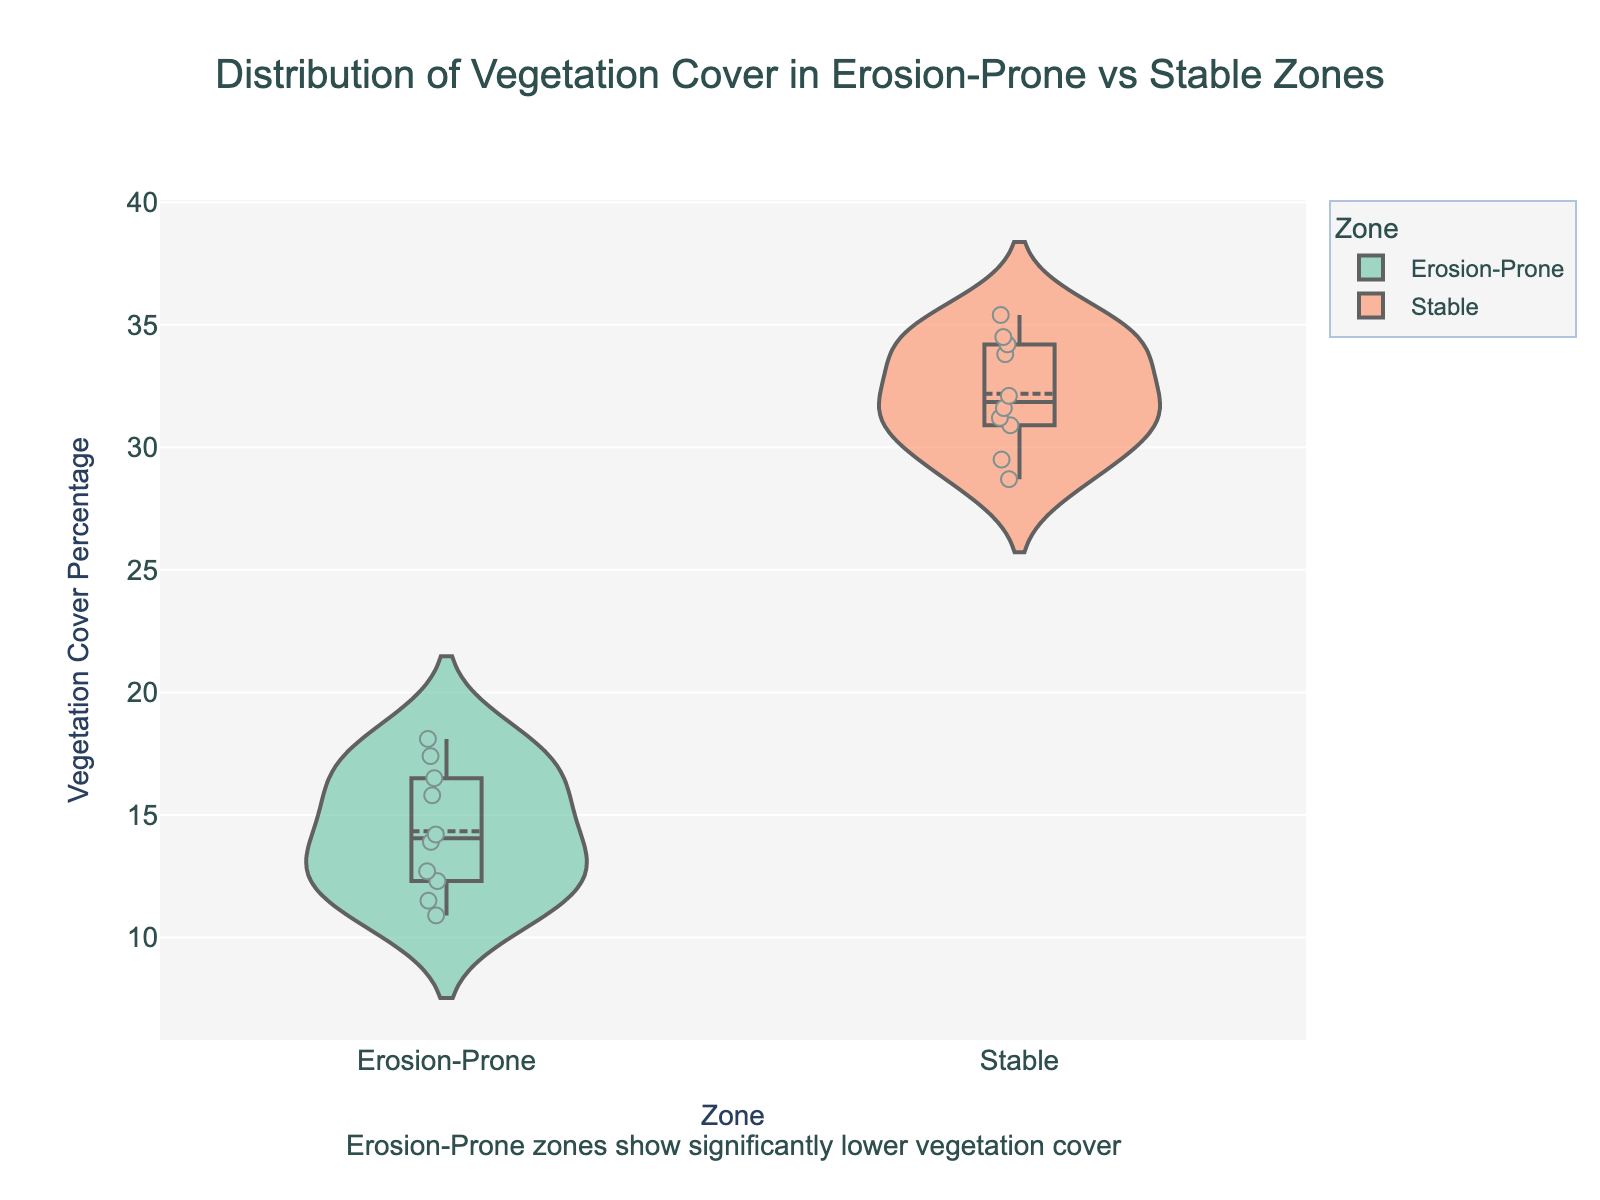What is the title of the chart? The title of the chart is located at the top and reads "Distribution of Vegetation Cover in Erosion-Prone vs Stable Zones".
Answer: Distribution of Vegetation Cover in Erosion-Prone vs Stable Zones How many zones are compared in this chart? The chart compares two zones, which can be identified by the separate violin plots labeled on the x-axis.
Answer: Two Which zone has a higher overall median vegetation cover percentage? By looking at the central line within each violin plot, the Stable zone has a higher median, which is clearly shown closer to the top.
Answer: Stable What is the approximate median vegetation cover percentage for the Erosion-Prone zone? The central line inside the violin plot for the Erosion-Prone zone indicates the median value, which appears to be around 14%.
Answer: 14% Compare the interquartile ranges (IQR) for both zones. Which zone has a wider IQR? The IQR is represented by the width of the box plot within the violin. The Stable zone has a wider IQR as its box plot is larger than that of the Erosion-Prone zone.
Answer: Stable Looking at the data points within the Erosion-Prone zone, what is the lowest vegetation cover percentage observed? The most spread out point at the bottom of the jittered points in the Erosion-Prone zone indicates the lowest observed value, which is around 10.9%.
Answer: 10.9% What can be inferred about the variability in vegetation cover between the zones? The Stable zone shows a broader distribution and higher variability in the violin shape, while the Erosion-Prone zone exhibits a narrower, more central distribution, indicating less variability.
Answer: Stable zone has higher variability What is the average vegetation cover percentage for the Stable zone? To get the average, sum up the individual values: 34.5 + 28.7 + 31.2 + 33.8 + 29.5 + 32.1 + 35.4 + 30.9 + 34.2 + 31.6 = 322.9, then divide by the number of points: 322.9/10 = 32.29%.
Answer: 32.29% Why does the annotation claim that "Erosion-Prone zones show significantly lower vegetation cover"? The annotation is based on the clear visual separation between the violin plots where the Erosion-Prone zone shows consistently lower vegetation cover percentages compared to the Stable zone.
Answer: Erosion-Prone zone has lower values 